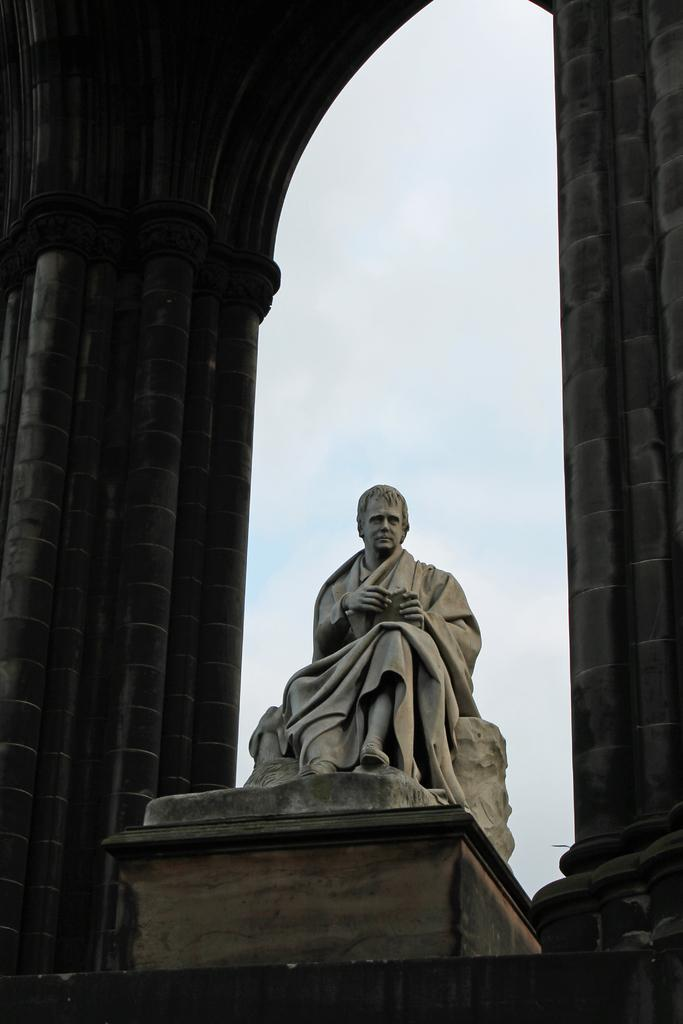What is the main subject of the image? There is a statue in the image. What is the statue standing on? There is a pedestal in the image. What other objects can be seen in the image? There are poles in the image. What is visible in the background of the image? The sky is visible in the image. What type of orange can be seen growing on the statue in the image? There is no orange present in the image, and the statue is not a tree or plant. 